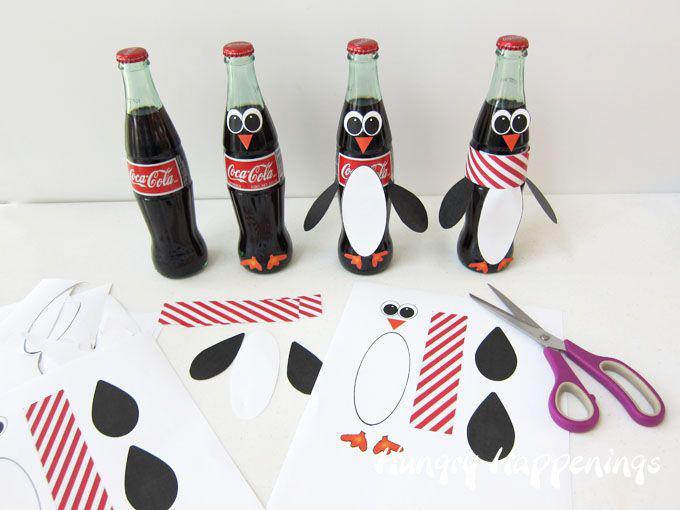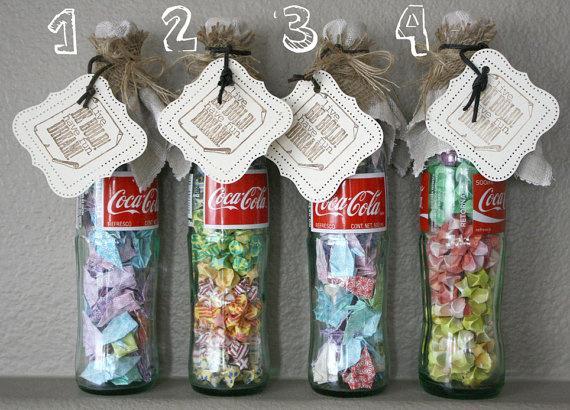The first image is the image on the left, the second image is the image on the right. For the images shown, is this caption "There is no more than three bottles in the right image." true? Answer yes or no. No. 